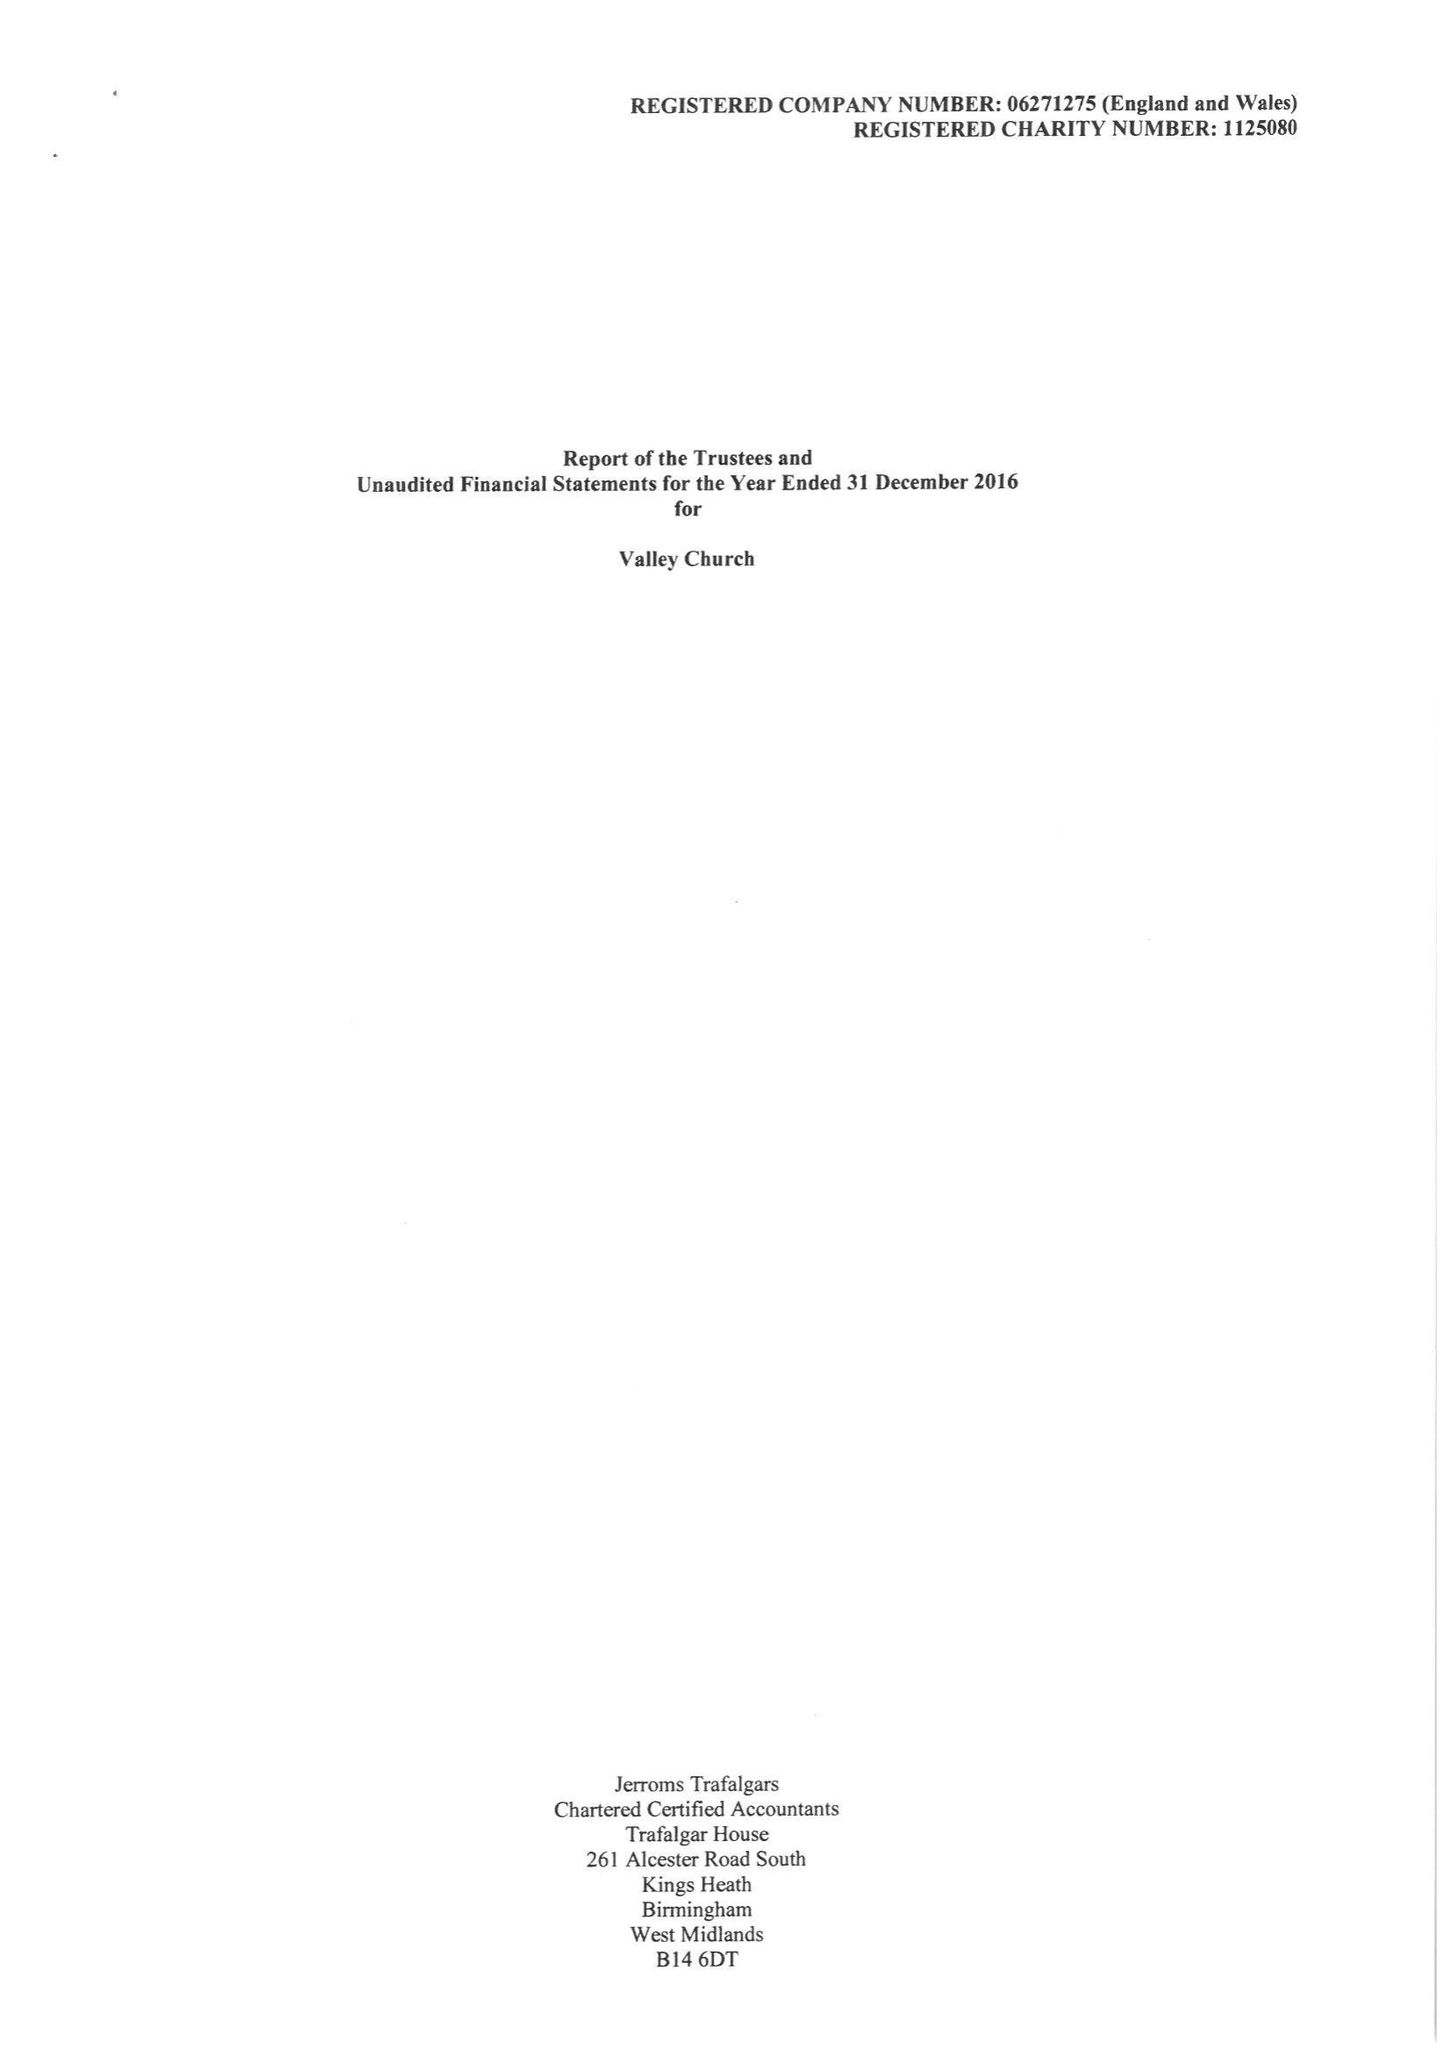What is the value for the address__post_town?
Answer the question using a single word or phrase. PRESTON 